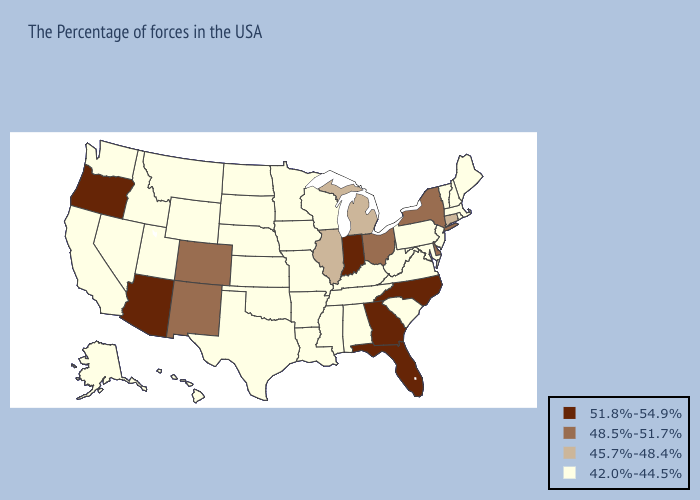Name the states that have a value in the range 51.8%-54.9%?
Write a very short answer. North Carolina, Florida, Georgia, Indiana, Arizona, Oregon. Does Connecticut have a higher value than Indiana?
Give a very brief answer. No. What is the highest value in states that border Nevada?
Keep it brief. 51.8%-54.9%. What is the highest value in the South ?
Short answer required. 51.8%-54.9%. Does Kansas have the lowest value in the MidWest?
Answer briefly. Yes. What is the value of Alaska?
Give a very brief answer. 42.0%-44.5%. Name the states that have a value in the range 45.7%-48.4%?
Quick response, please. Connecticut, Michigan, Illinois. Does Florida have the highest value in the USA?
Keep it brief. Yes. Does Ohio have the lowest value in the USA?
Concise answer only. No. What is the value of West Virginia?
Keep it brief. 42.0%-44.5%. Name the states that have a value in the range 42.0%-44.5%?
Be succinct. Maine, Massachusetts, Rhode Island, New Hampshire, Vermont, New Jersey, Maryland, Pennsylvania, Virginia, South Carolina, West Virginia, Kentucky, Alabama, Tennessee, Wisconsin, Mississippi, Louisiana, Missouri, Arkansas, Minnesota, Iowa, Kansas, Nebraska, Oklahoma, Texas, South Dakota, North Dakota, Wyoming, Utah, Montana, Idaho, Nevada, California, Washington, Alaska, Hawaii. Name the states that have a value in the range 48.5%-51.7%?
Answer briefly. New York, Delaware, Ohio, Colorado, New Mexico. What is the value of Nebraska?
Concise answer only. 42.0%-44.5%. What is the value of Washington?
Concise answer only. 42.0%-44.5%. 